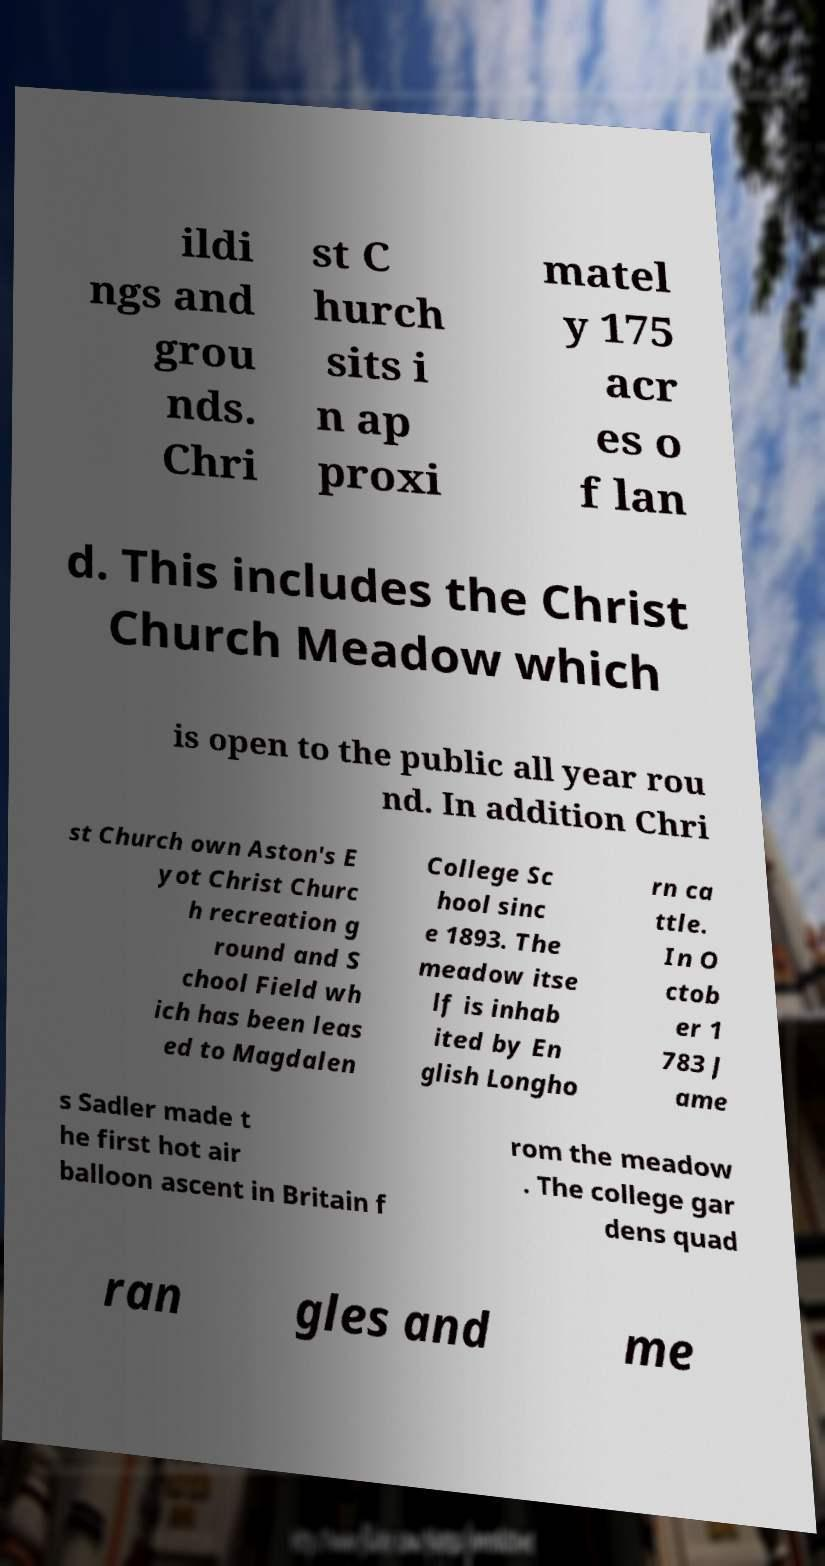What messages or text are displayed in this image? I need them in a readable, typed format. ildi ngs and grou nds. Chri st C hurch sits i n ap proxi matel y 175 acr es o f lan d. This includes the Christ Church Meadow which is open to the public all year rou nd. In addition Chri st Church own Aston's E yot Christ Churc h recreation g round and S chool Field wh ich has been leas ed to Magdalen College Sc hool sinc e 1893. The meadow itse lf is inhab ited by En glish Longho rn ca ttle. In O ctob er 1 783 J ame s Sadler made t he first hot air balloon ascent in Britain f rom the meadow . The college gar dens quad ran gles and me 